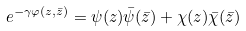<formula> <loc_0><loc_0><loc_500><loc_500>e ^ { - \gamma \varphi ( z , \bar { z } ) } = \psi ( z ) \bar { \psi } ( \bar { z } ) + \chi ( z ) \bar { \chi } ( \bar { z } )</formula> 